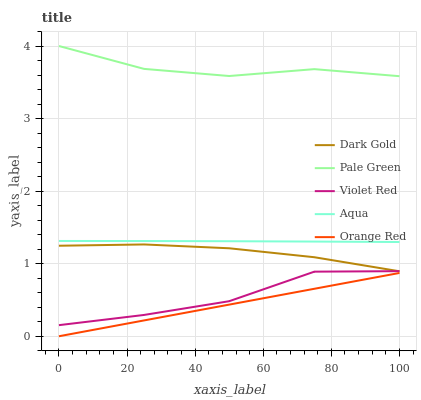Does Orange Red have the minimum area under the curve?
Answer yes or no. Yes. Does Pale Green have the maximum area under the curve?
Answer yes or no. Yes. Does Aqua have the minimum area under the curve?
Answer yes or no. No. Does Aqua have the maximum area under the curve?
Answer yes or no. No. Is Orange Red the smoothest?
Answer yes or no. Yes. Is Violet Red the roughest?
Answer yes or no. Yes. Is Pale Green the smoothest?
Answer yes or no. No. Is Pale Green the roughest?
Answer yes or no. No. Does Orange Red have the lowest value?
Answer yes or no. Yes. Does Aqua have the lowest value?
Answer yes or no. No. Does Pale Green have the highest value?
Answer yes or no. Yes. Does Aqua have the highest value?
Answer yes or no. No. Is Orange Red less than Violet Red?
Answer yes or no. Yes. Is Violet Red greater than Orange Red?
Answer yes or no. Yes. Does Dark Gold intersect Violet Red?
Answer yes or no. Yes. Is Dark Gold less than Violet Red?
Answer yes or no. No. Is Dark Gold greater than Violet Red?
Answer yes or no. No. Does Orange Red intersect Violet Red?
Answer yes or no. No. 